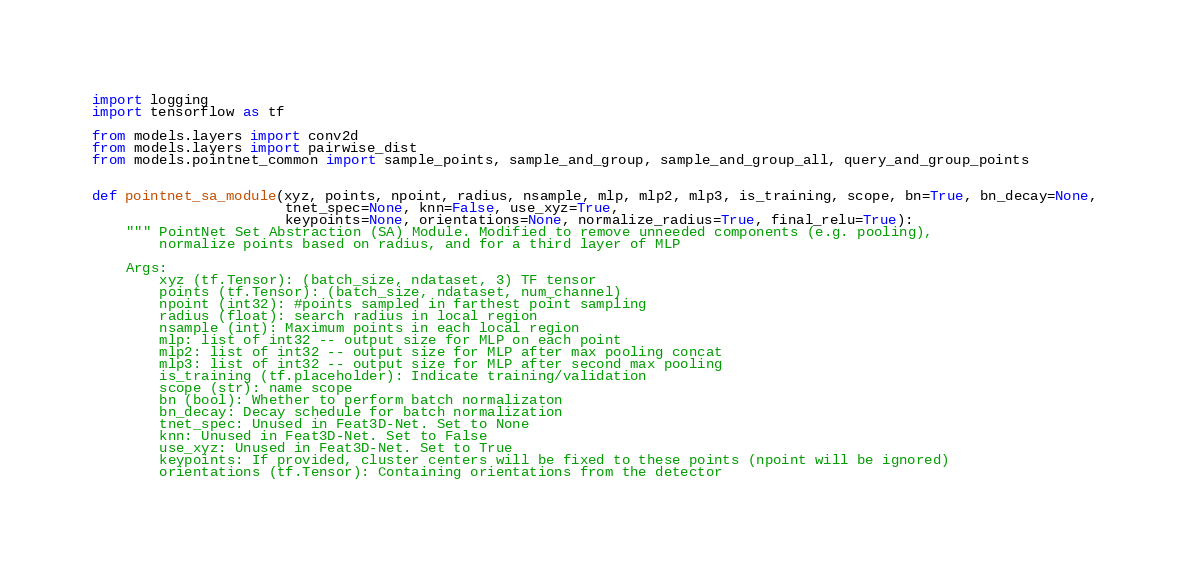<code> <loc_0><loc_0><loc_500><loc_500><_Python_>import logging
import tensorflow as tf

from models.layers import conv2d
from models.layers import pairwise_dist
from models.pointnet_common import sample_points, sample_and_group, sample_and_group_all, query_and_group_points


def pointnet_sa_module(xyz, points, npoint, radius, nsample, mlp, mlp2, mlp3, is_training, scope, bn=True, bn_decay=None,
                       tnet_spec=None, knn=False, use_xyz=True,
                       keypoints=None, orientations=None, normalize_radius=True, final_relu=True):
    """ PointNet Set Abstraction (SA) Module. Modified to remove unneeded components (e.g. pooling),
        normalize points based on radius, and for a third layer of MLP

    Args:
        xyz (tf.Tensor): (batch_size, ndataset, 3) TF tensor
        points (tf.Tensor): (batch_size, ndataset, num_channel)
        npoint (int32): #points sampled in farthest point sampling
        radius (float): search radius in local region
        nsample (int): Maximum points in each local region
        mlp: list of int32 -- output size for MLP on each point
        mlp2: list of int32 -- output size for MLP after max pooling concat
        mlp3: list of int32 -- output size for MLP after second max pooling
        is_training (tf.placeholder): Indicate training/validation
        scope (str): name scope
        bn (bool): Whether to perform batch normalizaton
        bn_decay: Decay schedule for batch normalization
        tnet_spec: Unused in Feat3D-Net. Set to None
        knn: Unused in Feat3D-Net. Set to False
        use_xyz: Unused in Feat3D-Net. Set to True
        keypoints: If provided, cluster centers will be fixed to these points (npoint will be ignored)
        orientations (tf.Tensor): Containing orientations from the detector</code> 